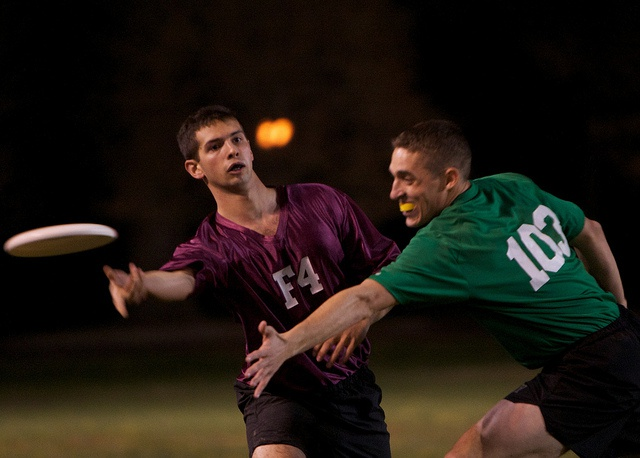Describe the objects in this image and their specific colors. I can see people in black, darkgreen, brown, and maroon tones, people in black, maroon, brown, and purple tones, and frisbee in black, maroon, and pink tones in this image. 